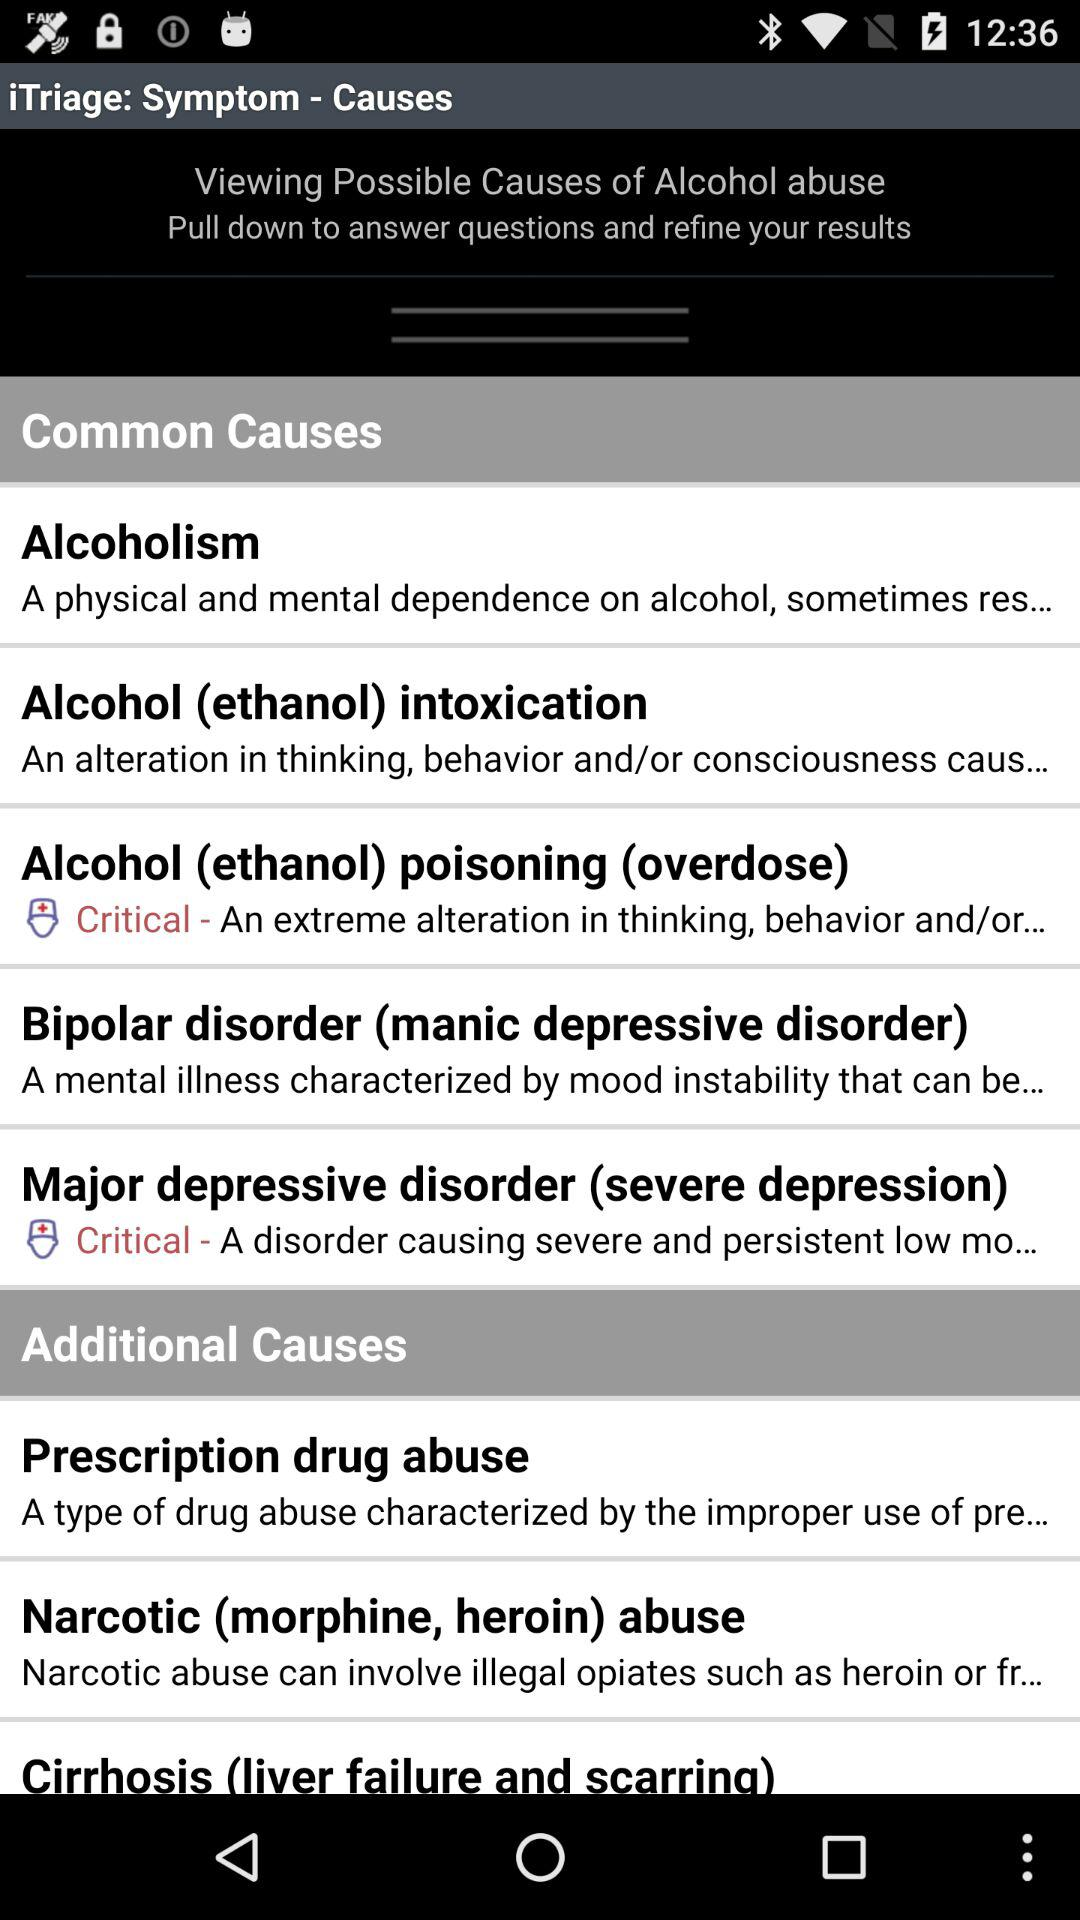Is "Additional Causes" on or off?
When the provided information is insufficient, respond with <no answer>. <no answer> 